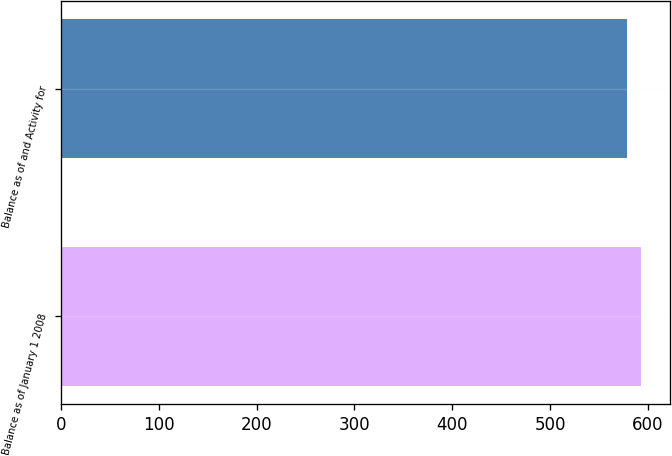Convert chart to OTSL. <chart><loc_0><loc_0><loc_500><loc_500><bar_chart><fcel>Balance as of January 1 2008<fcel>Balance as of and Activity for<nl><fcel>593<fcel>578<nl></chart> 